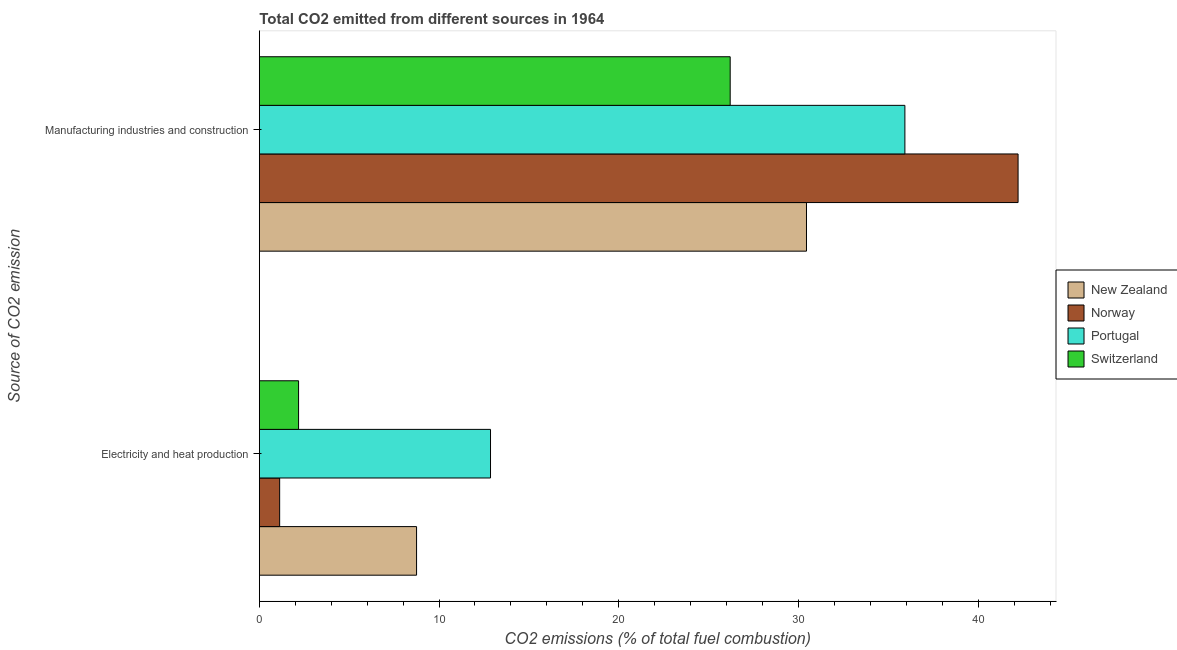How many groups of bars are there?
Provide a succinct answer. 2. Are the number of bars on each tick of the Y-axis equal?
Offer a very short reply. Yes. What is the label of the 2nd group of bars from the top?
Provide a succinct answer. Electricity and heat production. What is the co2 emissions due to electricity and heat production in New Zealand?
Offer a terse response. 8.75. Across all countries, what is the maximum co2 emissions due to manufacturing industries?
Offer a terse response. 42.22. Across all countries, what is the minimum co2 emissions due to electricity and heat production?
Ensure brevity in your answer.  1.13. In which country was the co2 emissions due to electricity and heat production maximum?
Keep it short and to the point. Portugal. What is the total co2 emissions due to manufacturing industries in the graph?
Offer a very short reply. 134.79. What is the difference between the co2 emissions due to manufacturing industries in Portugal and that in New Zealand?
Provide a short and direct response. 5.48. What is the difference between the co2 emissions due to electricity and heat production in New Zealand and the co2 emissions due to manufacturing industries in Switzerland?
Your answer should be very brief. -17.45. What is the average co2 emissions due to manufacturing industries per country?
Your answer should be compact. 33.7. What is the difference between the co2 emissions due to electricity and heat production and co2 emissions due to manufacturing industries in Portugal?
Your answer should be compact. -23.06. In how many countries, is the co2 emissions due to electricity and heat production greater than 8 %?
Your answer should be compact. 2. What is the ratio of the co2 emissions due to electricity and heat production in Switzerland to that in Portugal?
Give a very brief answer. 0.17. Is the co2 emissions due to manufacturing industries in Switzerland less than that in Portugal?
Ensure brevity in your answer.  Yes. In how many countries, is the co2 emissions due to manufacturing industries greater than the average co2 emissions due to manufacturing industries taken over all countries?
Keep it short and to the point. 2. What does the 1st bar from the bottom in Electricity and heat production represents?
Your response must be concise. New Zealand. What is the difference between two consecutive major ticks on the X-axis?
Ensure brevity in your answer.  10. Are the values on the major ticks of X-axis written in scientific E-notation?
Provide a succinct answer. No. Does the graph contain any zero values?
Your answer should be very brief. No. Does the graph contain grids?
Your response must be concise. No. How many legend labels are there?
Offer a terse response. 4. How are the legend labels stacked?
Your response must be concise. Vertical. What is the title of the graph?
Provide a short and direct response. Total CO2 emitted from different sources in 1964. What is the label or title of the X-axis?
Offer a very short reply. CO2 emissions (% of total fuel combustion). What is the label or title of the Y-axis?
Your answer should be compact. Source of CO2 emission. What is the CO2 emissions (% of total fuel combustion) in New Zealand in Electricity and heat production?
Offer a very short reply. 8.75. What is the CO2 emissions (% of total fuel combustion) of Norway in Electricity and heat production?
Ensure brevity in your answer.  1.13. What is the CO2 emissions (% of total fuel combustion) in Portugal in Electricity and heat production?
Offer a terse response. 12.86. What is the CO2 emissions (% of total fuel combustion) of Switzerland in Electricity and heat production?
Give a very brief answer. 2.18. What is the CO2 emissions (% of total fuel combustion) in New Zealand in Manufacturing industries and construction?
Ensure brevity in your answer.  30.45. What is the CO2 emissions (% of total fuel combustion) in Norway in Manufacturing industries and construction?
Keep it short and to the point. 42.22. What is the CO2 emissions (% of total fuel combustion) of Portugal in Manufacturing industries and construction?
Offer a terse response. 35.92. What is the CO2 emissions (% of total fuel combustion) in Switzerland in Manufacturing industries and construction?
Keep it short and to the point. 26.2. Across all Source of CO2 emission, what is the maximum CO2 emissions (% of total fuel combustion) in New Zealand?
Offer a very short reply. 30.45. Across all Source of CO2 emission, what is the maximum CO2 emissions (% of total fuel combustion) of Norway?
Provide a succinct answer. 42.22. Across all Source of CO2 emission, what is the maximum CO2 emissions (% of total fuel combustion) of Portugal?
Your answer should be very brief. 35.92. Across all Source of CO2 emission, what is the maximum CO2 emissions (% of total fuel combustion) of Switzerland?
Ensure brevity in your answer.  26.2. Across all Source of CO2 emission, what is the minimum CO2 emissions (% of total fuel combustion) in New Zealand?
Your answer should be very brief. 8.75. Across all Source of CO2 emission, what is the minimum CO2 emissions (% of total fuel combustion) in Norway?
Provide a succinct answer. 1.13. Across all Source of CO2 emission, what is the minimum CO2 emissions (% of total fuel combustion) of Portugal?
Provide a succinct answer. 12.86. Across all Source of CO2 emission, what is the minimum CO2 emissions (% of total fuel combustion) of Switzerland?
Ensure brevity in your answer.  2.18. What is the total CO2 emissions (% of total fuel combustion) of New Zealand in the graph?
Give a very brief answer. 39.2. What is the total CO2 emissions (% of total fuel combustion) of Norway in the graph?
Offer a terse response. 43.35. What is the total CO2 emissions (% of total fuel combustion) of Portugal in the graph?
Offer a very short reply. 48.79. What is the total CO2 emissions (% of total fuel combustion) in Switzerland in the graph?
Keep it short and to the point. 28.38. What is the difference between the CO2 emissions (% of total fuel combustion) of New Zealand in Electricity and heat production and that in Manufacturing industries and construction?
Ensure brevity in your answer.  -21.7. What is the difference between the CO2 emissions (% of total fuel combustion) in Norway in Electricity and heat production and that in Manufacturing industries and construction?
Offer a terse response. -41.09. What is the difference between the CO2 emissions (% of total fuel combustion) of Portugal in Electricity and heat production and that in Manufacturing industries and construction?
Give a very brief answer. -23.06. What is the difference between the CO2 emissions (% of total fuel combustion) in Switzerland in Electricity and heat production and that in Manufacturing industries and construction?
Offer a very short reply. -24.02. What is the difference between the CO2 emissions (% of total fuel combustion) of New Zealand in Electricity and heat production and the CO2 emissions (% of total fuel combustion) of Norway in Manufacturing industries and construction?
Your answer should be compact. -33.47. What is the difference between the CO2 emissions (% of total fuel combustion) of New Zealand in Electricity and heat production and the CO2 emissions (% of total fuel combustion) of Portugal in Manufacturing industries and construction?
Your response must be concise. -27.17. What is the difference between the CO2 emissions (% of total fuel combustion) in New Zealand in Electricity and heat production and the CO2 emissions (% of total fuel combustion) in Switzerland in Manufacturing industries and construction?
Ensure brevity in your answer.  -17.45. What is the difference between the CO2 emissions (% of total fuel combustion) of Norway in Electricity and heat production and the CO2 emissions (% of total fuel combustion) of Portugal in Manufacturing industries and construction?
Provide a succinct answer. -34.79. What is the difference between the CO2 emissions (% of total fuel combustion) in Norway in Electricity and heat production and the CO2 emissions (% of total fuel combustion) in Switzerland in Manufacturing industries and construction?
Offer a very short reply. -25.07. What is the difference between the CO2 emissions (% of total fuel combustion) of Portugal in Electricity and heat production and the CO2 emissions (% of total fuel combustion) of Switzerland in Manufacturing industries and construction?
Give a very brief answer. -13.34. What is the average CO2 emissions (% of total fuel combustion) of New Zealand per Source of CO2 emission?
Your answer should be very brief. 19.6. What is the average CO2 emissions (% of total fuel combustion) in Norway per Source of CO2 emission?
Keep it short and to the point. 21.68. What is the average CO2 emissions (% of total fuel combustion) of Portugal per Source of CO2 emission?
Give a very brief answer. 24.39. What is the average CO2 emissions (% of total fuel combustion) in Switzerland per Source of CO2 emission?
Your response must be concise. 14.19. What is the difference between the CO2 emissions (% of total fuel combustion) in New Zealand and CO2 emissions (% of total fuel combustion) in Norway in Electricity and heat production?
Provide a succinct answer. 7.62. What is the difference between the CO2 emissions (% of total fuel combustion) of New Zealand and CO2 emissions (% of total fuel combustion) of Portugal in Electricity and heat production?
Your answer should be compact. -4.12. What is the difference between the CO2 emissions (% of total fuel combustion) in New Zealand and CO2 emissions (% of total fuel combustion) in Switzerland in Electricity and heat production?
Provide a short and direct response. 6.57. What is the difference between the CO2 emissions (% of total fuel combustion) of Norway and CO2 emissions (% of total fuel combustion) of Portugal in Electricity and heat production?
Make the answer very short. -11.73. What is the difference between the CO2 emissions (% of total fuel combustion) in Norway and CO2 emissions (% of total fuel combustion) in Switzerland in Electricity and heat production?
Offer a very short reply. -1.05. What is the difference between the CO2 emissions (% of total fuel combustion) of Portugal and CO2 emissions (% of total fuel combustion) of Switzerland in Electricity and heat production?
Your answer should be compact. 10.68. What is the difference between the CO2 emissions (% of total fuel combustion) in New Zealand and CO2 emissions (% of total fuel combustion) in Norway in Manufacturing industries and construction?
Keep it short and to the point. -11.77. What is the difference between the CO2 emissions (% of total fuel combustion) of New Zealand and CO2 emissions (% of total fuel combustion) of Portugal in Manufacturing industries and construction?
Make the answer very short. -5.48. What is the difference between the CO2 emissions (% of total fuel combustion) of New Zealand and CO2 emissions (% of total fuel combustion) of Switzerland in Manufacturing industries and construction?
Keep it short and to the point. 4.25. What is the difference between the CO2 emissions (% of total fuel combustion) in Norway and CO2 emissions (% of total fuel combustion) in Portugal in Manufacturing industries and construction?
Ensure brevity in your answer.  6.3. What is the difference between the CO2 emissions (% of total fuel combustion) in Norway and CO2 emissions (% of total fuel combustion) in Switzerland in Manufacturing industries and construction?
Provide a short and direct response. 16.02. What is the difference between the CO2 emissions (% of total fuel combustion) of Portugal and CO2 emissions (% of total fuel combustion) of Switzerland in Manufacturing industries and construction?
Provide a short and direct response. 9.72. What is the ratio of the CO2 emissions (% of total fuel combustion) of New Zealand in Electricity and heat production to that in Manufacturing industries and construction?
Make the answer very short. 0.29. What is the ratio of the CO2 emissions (% of total fuel combustion) of Norway in Electricity and heat production to that in Manufacturing industries and construction?
Offer a terse response. 0.03. What is the ratio of the CO2 emissions (% of total fuel combustion) of Portugal in Electricity and heat production to that in Manufacturing industries and construction?
Keep it short and to the point. 0.36. What is the ratio of the CO2 emissions (% of total fuel combustion) of Switzerland in Electricity and heat production to that in Manufacturing industries and construction?
Give a very brief answer. 0.08. What is the difference between the highest and the second highest CO2 emissions (% of total fuel combustion) in New Zealand?
Provide a succinct answer. 21.7. What is the difference between the highest and the second highest CO2 emissions (% of total fuel combustion) in Norway?
Your response must be concise. 41.09. What is the difference between the highest and the second highest CO2 emissions (% of total fuel combustion) of Portugal?
Your answer should be compact. 23.06. What is the difference between the highest and the second highest CO2 emissions (% of total fuel combustion) in Switzerland?
Give a very brief answer. 24.02. What is the difference between the highest and the lowest CO2 emissions (% of total fuel combustion) of New Zealand?
Your answer should be compact. 21.7. What is the difference between the highest and the lowest CO2 emissions (% of total fuel combustion) of Norway?
Ensure brevity in your answer.  41.09. What is the difference between the highest and the lowest CO2 emissions (% of total fuel combustion) of Portugal?
Provide a short and direct response. 23.06. What is the difference between the highest and the lowest CO2 emissions (% of total fuel combustion) of Switzerland?
Ensure brevity in your answer.  24.02. 